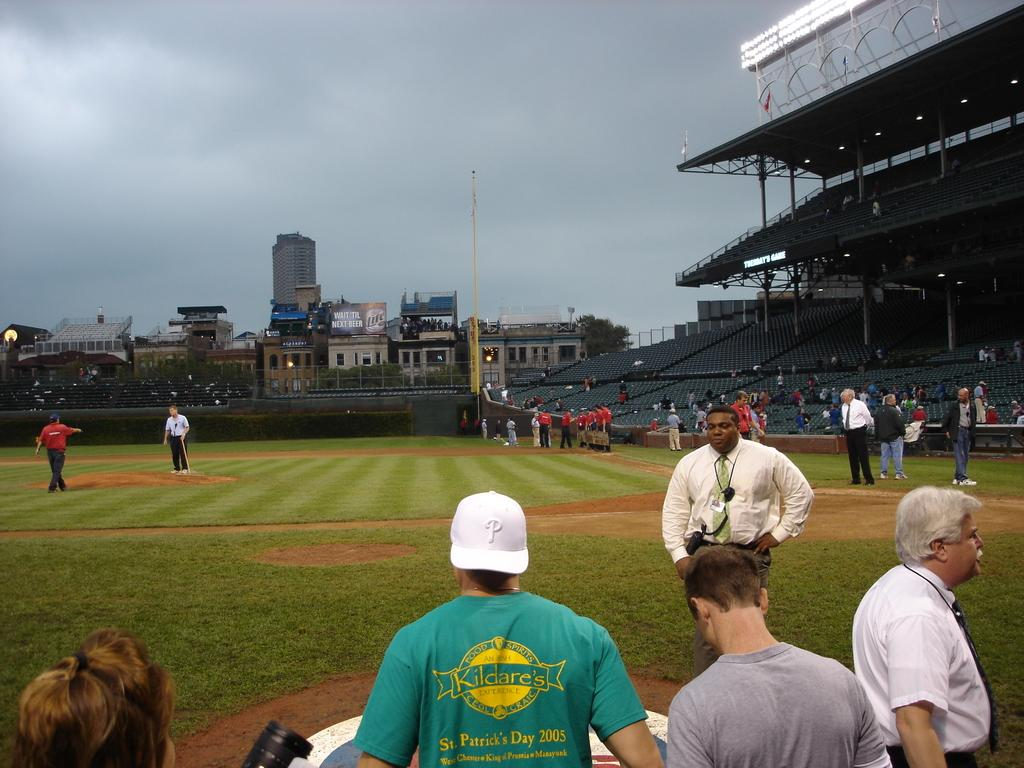<image>
Summarize the visual content of the image. A baseball stadium has only a handful of people in it and one of them is wearing a green shirt that says Kildare's. 